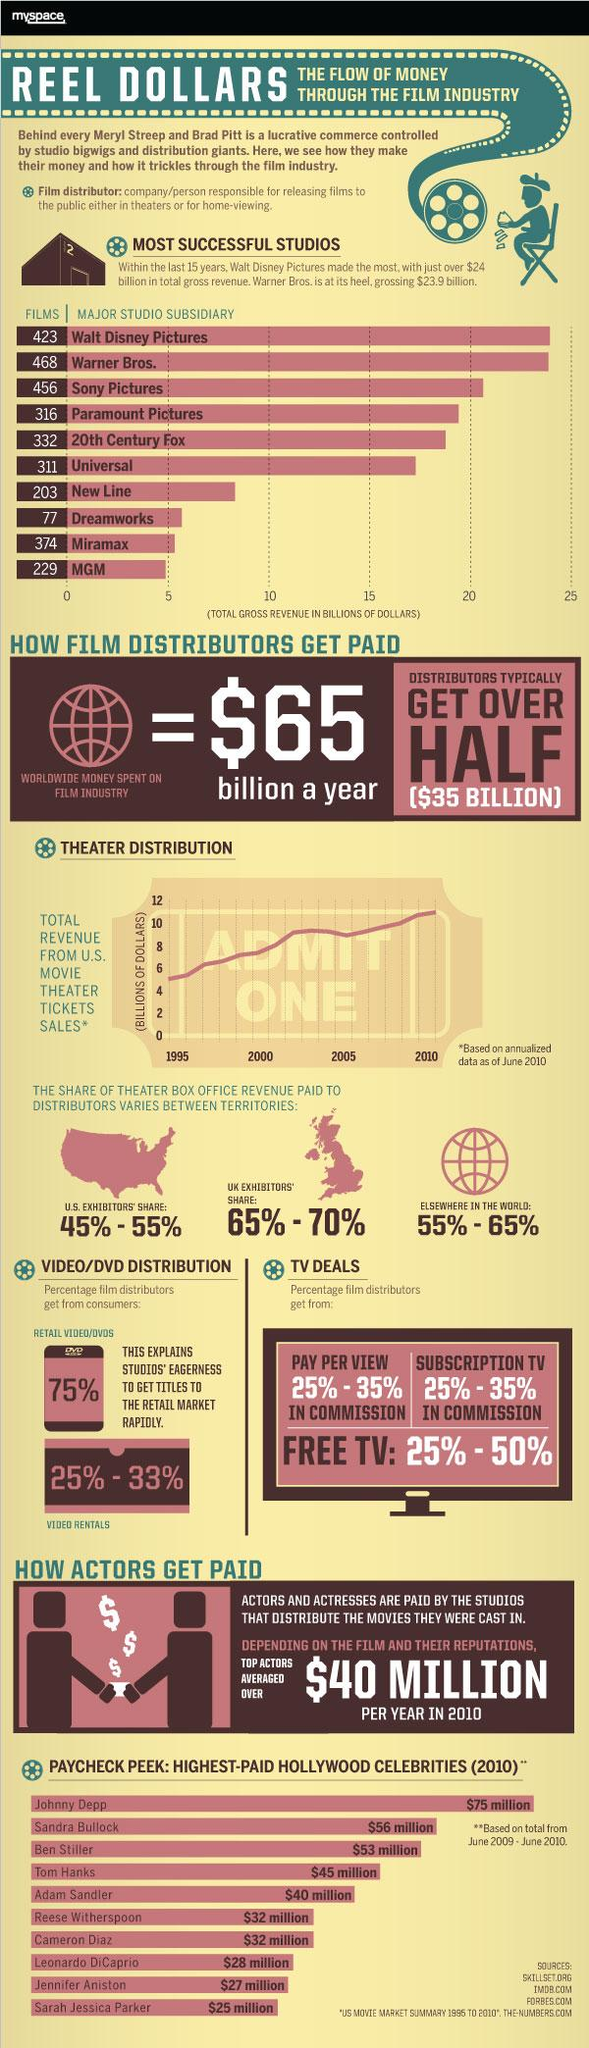Indicate a few pertinent items in this graphic. In the year 1995, the total revenue generated from movie ticket sales in the United States was approximately 5 billion dollars. Sandra Bullock was the second most highly paid celebrity in Hollywood in 2010. In 2010, the pay gap between the highest paid and second highest paid celebrities in Hollywood was approximately 19 million dollars. The maximum percentage that film distributors receive from free TV is 50%. The total number of films produced by the top five most successful studios in Hollywood from 1995 to present is [object of interest]. 